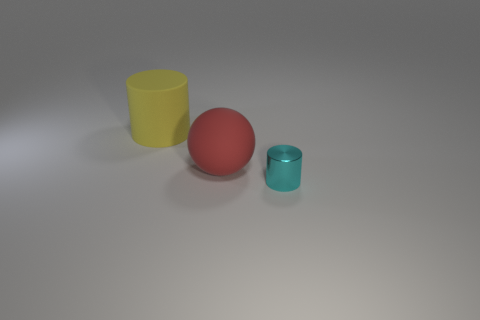Subtract all yellow cylinders. How many cylinders are left? 1 Subtract 1 cylinders. How many cylinders are left? 1 Add 3 small shiny objects. How many objects exist? 6 Subtract all cylinders. How many objects are left? 1 Subtract 1 red balls. How many objects are left? 2 Subtract all brown balls. Subtract all purple cylinders. How many balls are left? 1 Subtract all gray blocks. How many yellow cylinders are left? 1 Subtract all big purple blocks. Subtract all yellow matte things. How many objects are left? 2 Add 3 large red matte things. How many large red matte things are left? 4 Add 3 small yellow shiny objects. How many small yellow shiny objects exist? 3 